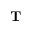<formula> <loc_0><loc_0><loc_500><loc_500>T</formula> 